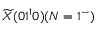Convert formula to latex. <formula><loc_0><loc_0><loc_500><loc_500>\widetilde { X } ( 0 1 ^ { 1 } 0 ) ( N = 1 ^ { - } )</formula> 